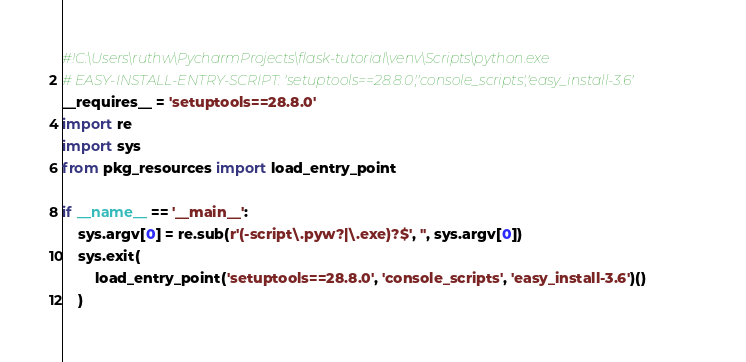<code> <loc_0><loc_0><loc_500><loc_500><_Python_>#!C:\Users\ruthw\PycharmProjects\flask-tutorial\venv\Scripts\python.exe
# EASY-INSTALL-ENTRY-SCRIPT: 'setuptools==28.8.0','console_scripts','easy_install-3.6'
__requires__ = 'setuptools==28.8.0'
import re
import sys
from pkg_resources import load_entry_point

if __name__ == '__main__':
    sys.argv[0] = re.sub(r'(-script\.pyw?|\.exe)?$', '', sys.argv[0])
    sys.exit(
        load_entry_point('setuptools==28.8.0', 'console_scripts', 'easy_install-3.6')()
    )
</code> 